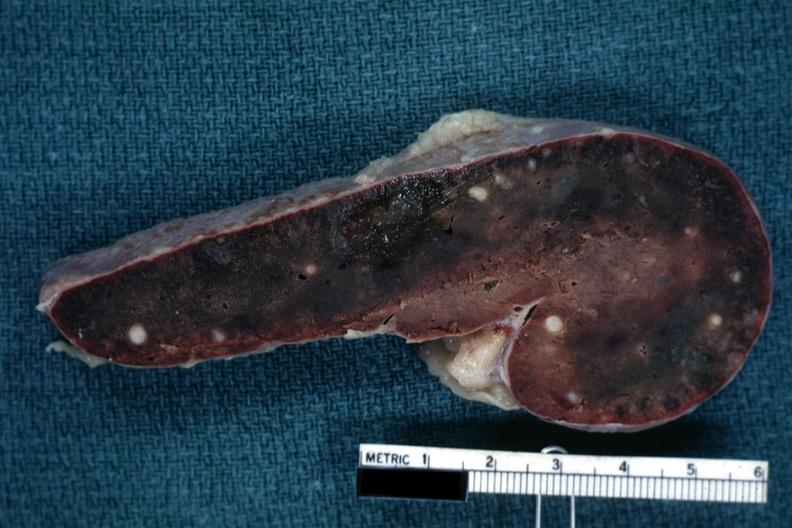what is present?
Answer the question using a single word or phrase. Hematologic 